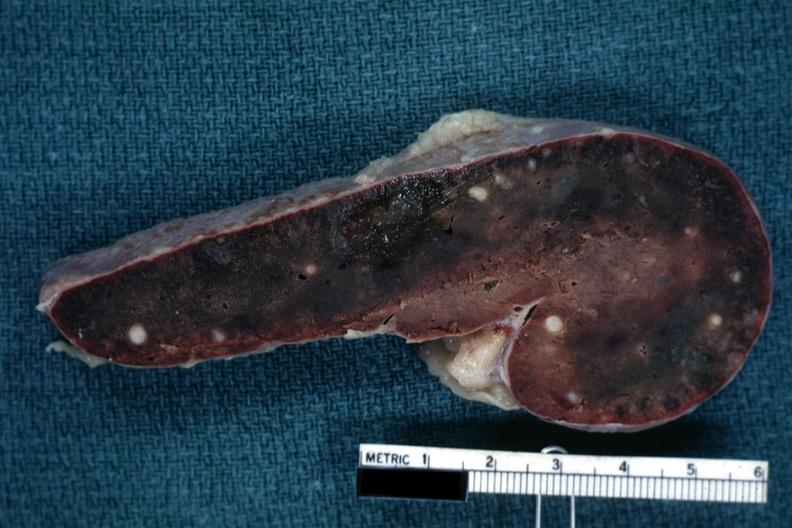what is present?
Answer the question using a single word or phrase. Hematologic 